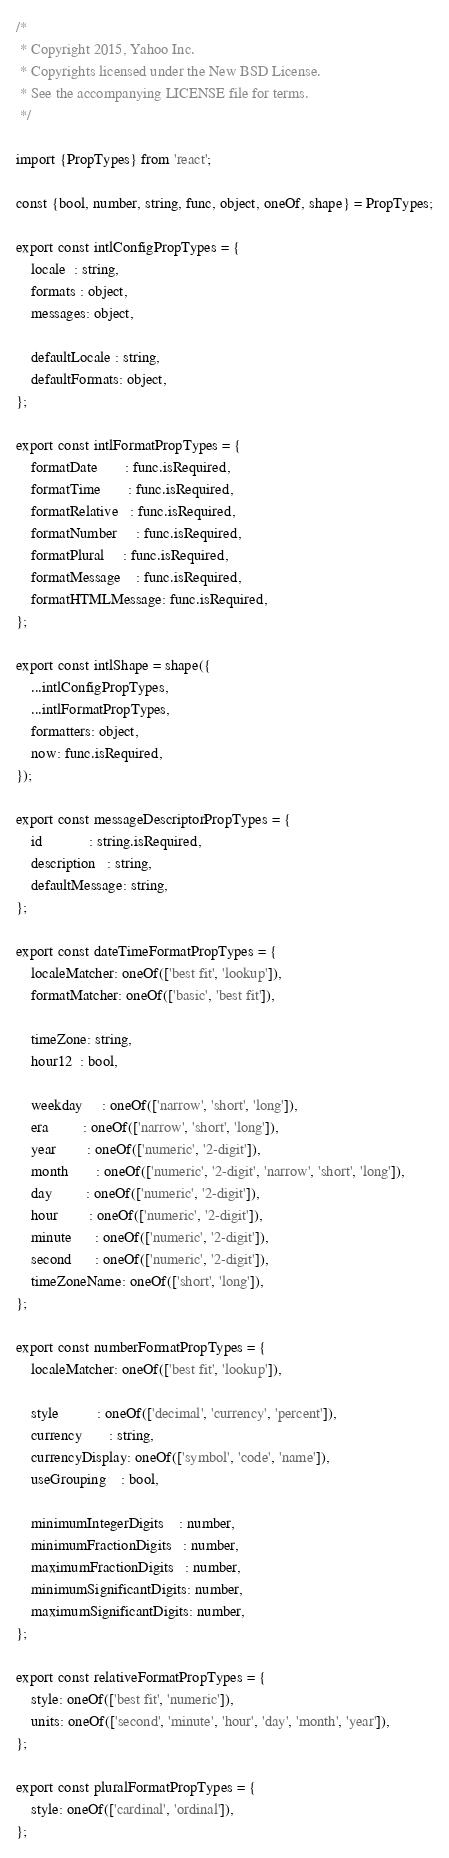<code> <loc_0><loc_0><loc_500><loc_500><_JavaScript_>/*
 * Copyright 2015, Yahoo Inc.
 * Copyrights licensed under the New BSD License.
 * See the accompanying LICENSE file for terms.
 */

import {PropTypes} from 'react';

const {bool, number, string, func, object, oneOf, shape} = PropTypes;

export const intlConfigPropTypes = {
    locale  : string,
    formats : object,
    messages: object,

    defaultLocale : string,
    defaultFormats: object,
};

export const intlFormatPropTypes = {
    formatDate       : func.isRequired,
    formatTime       : func.isRequired,
    formatRelative   : func.isRequired,
    formatNumber     : func.isRequired,
    formatPlural     : func.isRequired,
    formatMessage    : func.isRequired,
    formatHTMLMessage: func.isRequired,
};

export const intlShape = shape({
    ...intlConfigPropTypes,
    ...intlFormatPropTypes,
    formatters: object,
    now: func.isRequired,
});

export const messageDescriptorPropTypes = {
    id            : string.isRequired,
    description   : string,
    defaultMessage: string,
};

export const dateTimeFormatPropTypes = {
    localeMatcher: oneOf(['best fit', 'lookup']),
    formatMatcher: oneOf(['basic', 'best fit']),

    timeZone: string,
    hour12  : bool,

    weekday     : oneOf(['narrow', 'short', 'long']),
    era         : oneOf(['narrow', 'short', 'long']),
    year        : oneOf(['numeric', '2-digit']),
    month       : oneOf(['numeric', '2-digit', 'narrow', 'short', 'long']),
    day         : oneOf(['numeric', '2-digit']),
    hour        : oneOf(['numeric', '2-digit']),
    minute      : oneOf(['numeric', '2-digit']),
    second      : oneOf(['numeric', '2-digit']),
    timeZoneName: oneOf(['short', 'long']),
};

export const numberFormatPropTypes = {
    localeMatcher: oneOf(['best fit', 'lookup']),

    style          : oneOf(['decimal', 'currency', 'percent']),
    currency       : string,
    currencyDisplay: oneOf(['symbol', 'code', 'name']),
    useGrouping    : bool,

    minimumIntegerDigits    : number,
    minimumFractionDigits   : number,
    maximumFractionDigits   : number,
    minimumSignificantDigits: number,
    maximumSignificantDigits: number,
};

export const relativeFormatPropTypes = {
    style: oneOf(['best fit', 'numeric']),
    units: oneOf(['second', 'minute', 'hour', 'day', 'month', 'year']),
};

export const pluralFormatPropTypes = {
    style: oneOf(['cardinal', 'ordinal']),
};
</code> 